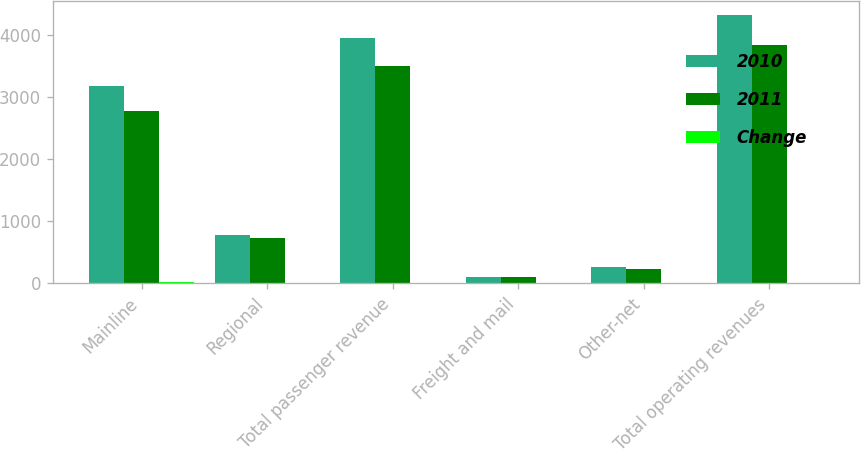Convert chart to OTSL. <chart><loc_0><loc_0><loc_500><loc_500><stacked_bar_chart><ecel><fcel>Mainline<fcel>Regional<fcel>Total passenger revenue<fcel>Freight and mail<fcel>Other-net<fcel>Total operating revenues<nl><fcel>2010<fcel>3176.2<fcel>774.5<fcel>3950.7<fcel>108.7<fcel>258.4<fcel>4317.8<nl><fcel>2011<fcel>2763.4<fcel>725.2<fcel>3488.6<fcel>106.2<fcel>237.5<fcel>3832.3<nl><fcel>Change<fcel>14.9<fcel>6.8<fcel>13.2<fcel>2.4<fcel>8.8<fcel>12.7<nl></chart> 